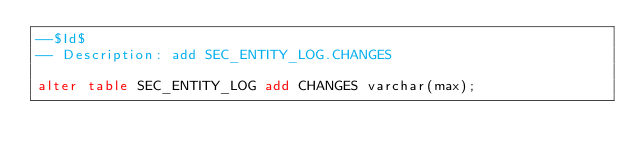Convert code to text. <code><loc_0><loc_0><loc_500><loc_500><_SQL_>--$Id$
-- Description: add SEC_ENTITY_LOG.CHANGES

alter table SEC_ENTITY_LOG add CHANGES varchar(max);
</code> 